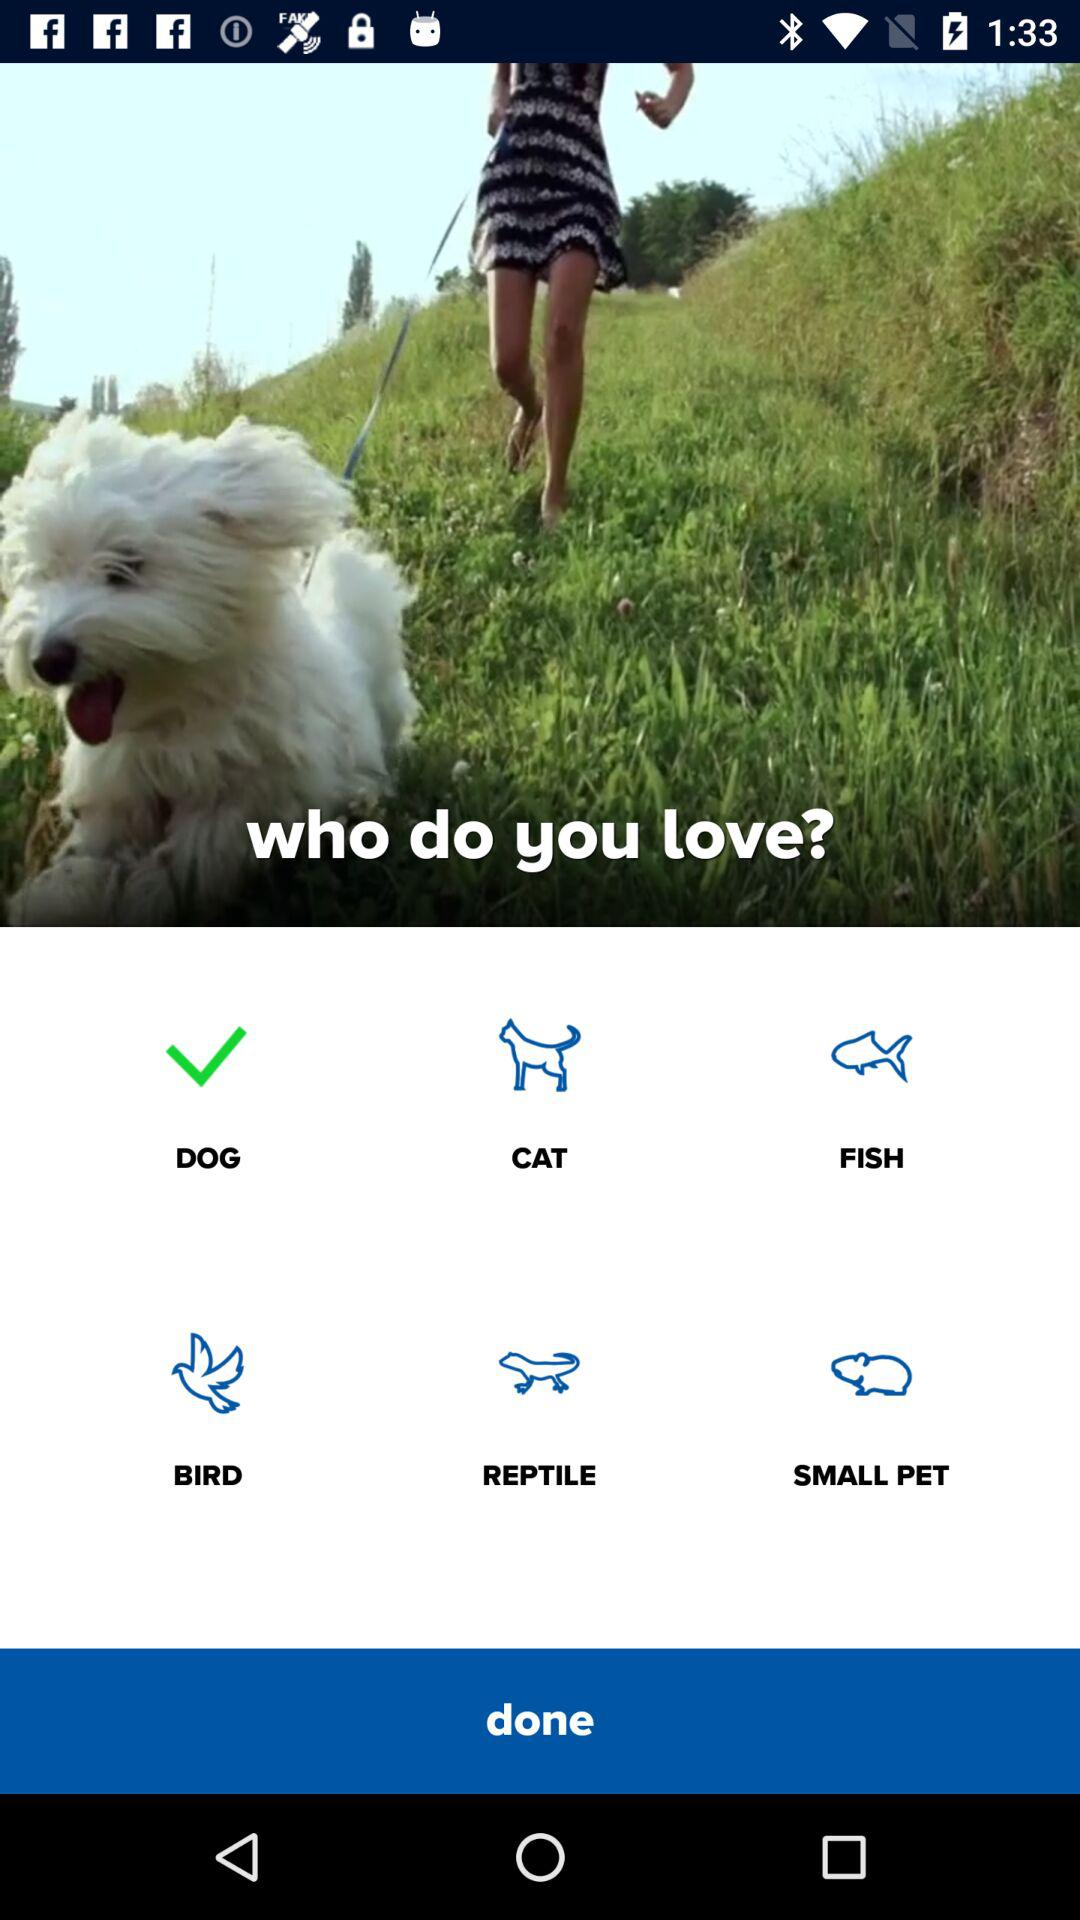How many pets are there in total?
Answer the question using a single word or phrase. 6 